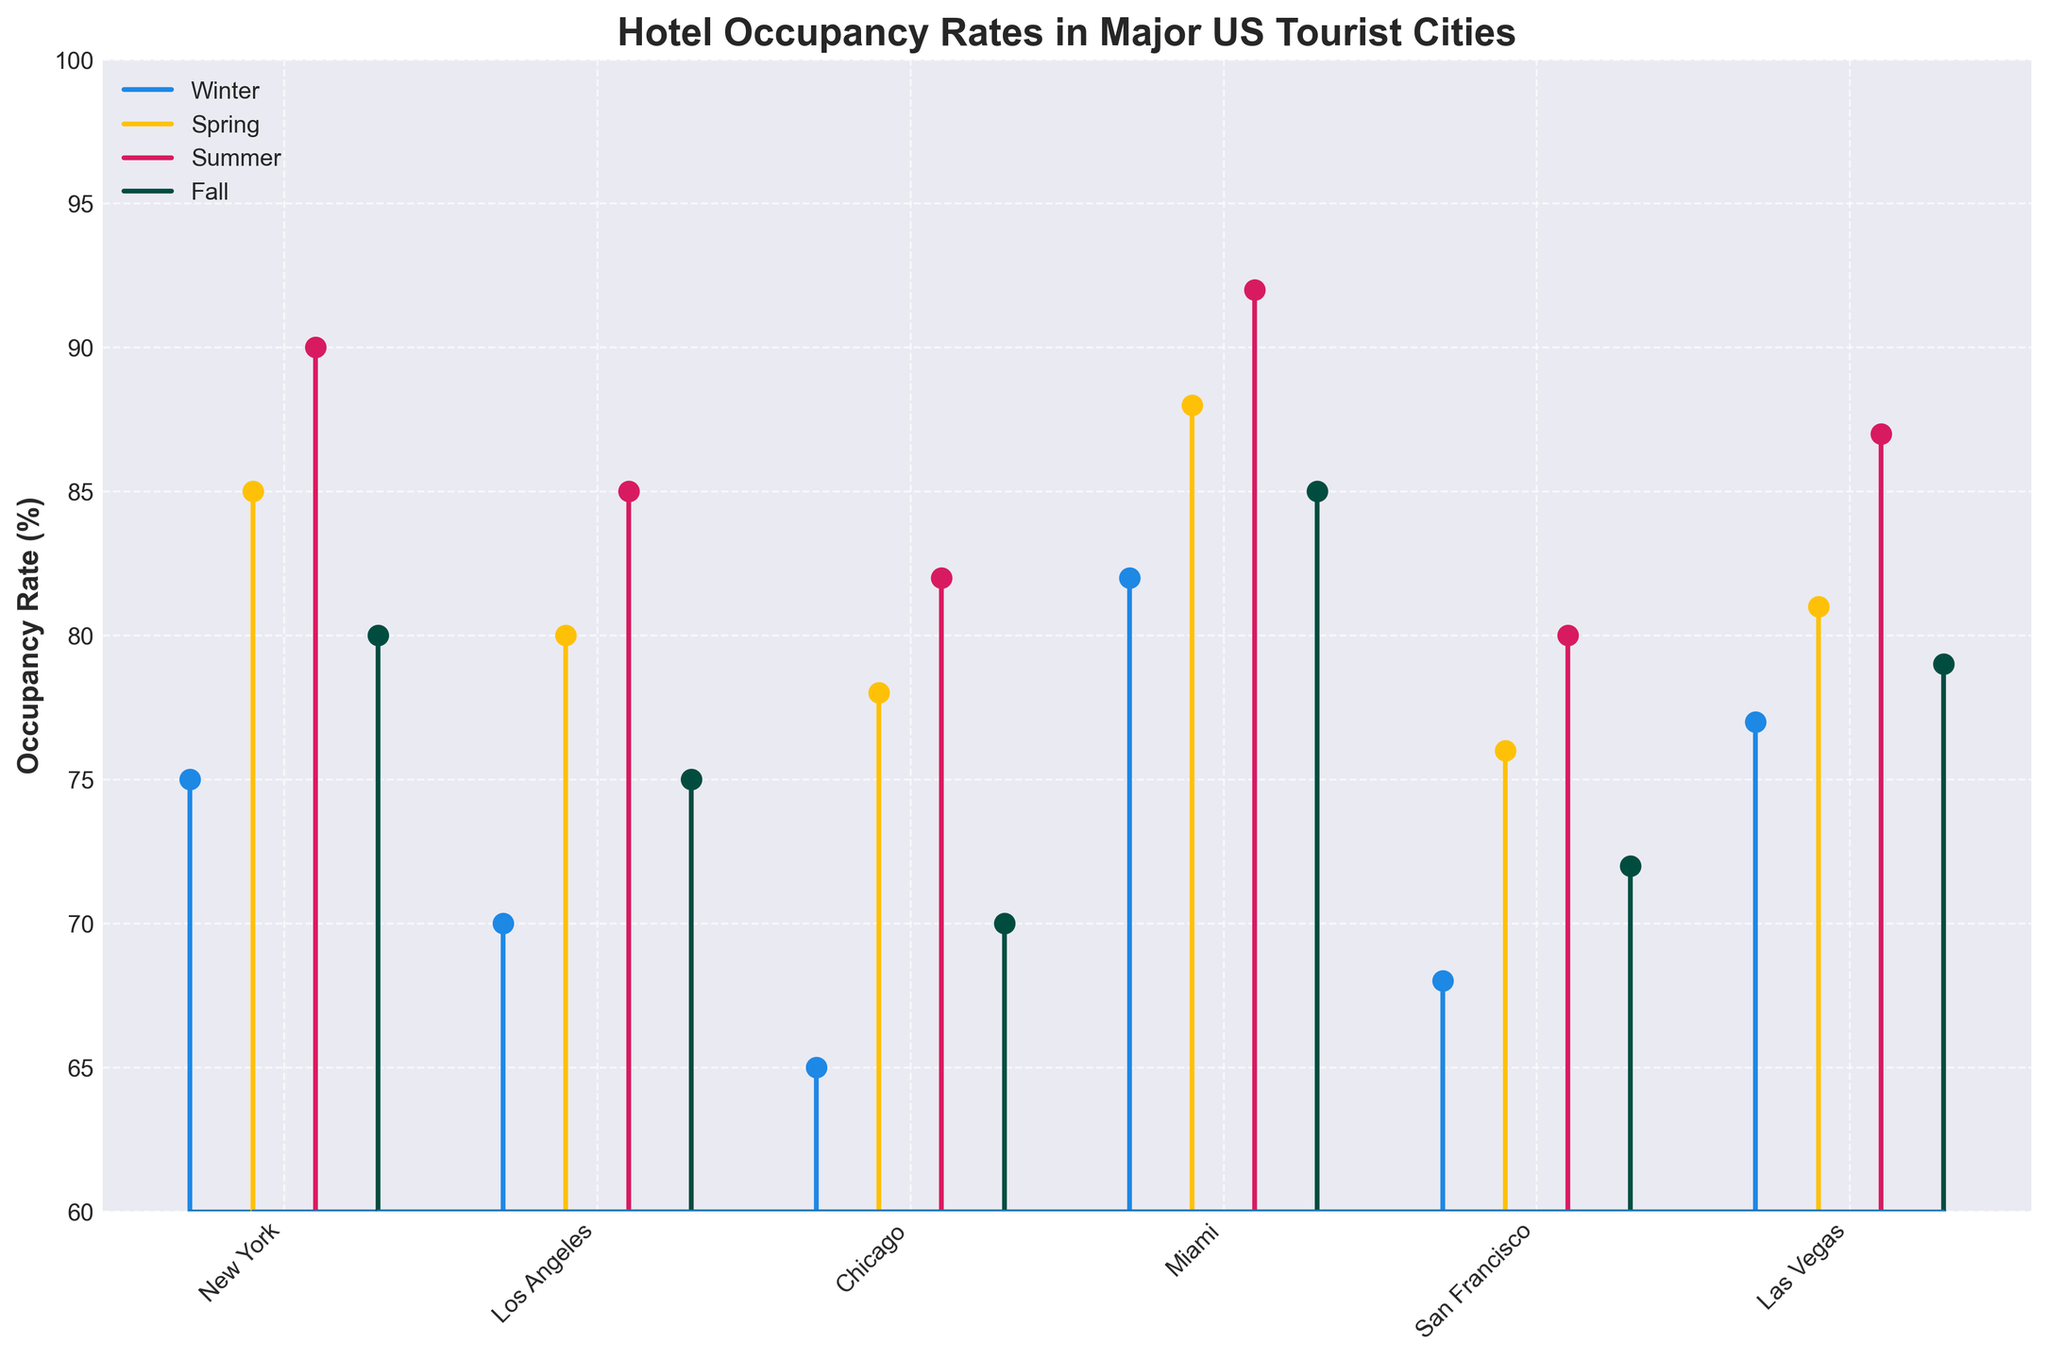What's the title of the plot? The title of the plot is typically found at the top and provides an overview of the information the plot is displaying.
Answer: Hotel Occupancy Rates in Major US Tourist Cities What's the minimum occupancy rate shown among all seasons and cities? To find the minimum occupancy rate, look at the y-axis and identify the lowest point of any stem. The lowest stem reaches up to 65%.
Answer: 65% Which city has the highest occupancy rate in the summer? Focus on the summer stems for each city. The highest stem in the summer is for Miami at 92%.
Answer: Miami Compare New York and Los Angeles in winter. Which city has a higher occupancy rate? Look at the winter stems for New York and Los Angeles. New York is at 75%, and Los Angeles is at 70%.
Answer: New York What's the average occupancy rate for Chicago across all seasons? To find the average, add the occupancy rates for Chicago (65, 78, 82, 70) and divide by the number of seasons (4). (65+78+82+70)/4 = 73.75
Answer: 73.75% Which season typically has the highest occupancy rate across all cities? Evaluate the stems for each season across all cities. Summer consistently shows higher rates compared to other seasons.
Answer: Summer Does Miami's occupancy rate increase or decrease from winter to summer? Compare the stems for Miami from winter (82%) to summer (92%). There is an increase.
Answer: Increase What is the range of occupancy rates for San Francisco? The range is found by subtracting the minimum occupancy rate of San Francisco from the maximum. The rates are 68% to 80%, so 80-68 = 12.
Answer: 12% Which city has the smallest variation in occupancy rates across all seasons? Calculate the range (difference between max and min rates) for each city. New York has a variation of 90-75 = 15, Los Angeles has 85-70 = 15, Miami has 92-82 = 10, Chicago has 82-65 = 17, San Francisco has 80-68 = 12, Las Vegas has 87-77 = 10. Miami and Las Vegas show the smallest variation.
Answer: Miami or Las Vegas In which city and season does the occupancy rate dip below the 70% mark? Look for any stem that is below the 70% mark on the y-axis. Chicago in winter is at 65%.
Answer: Chicago in winter 